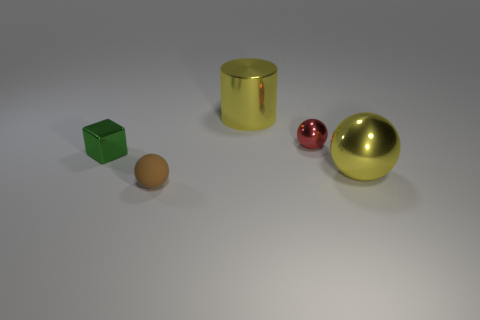What shape is the large metallic object that is the same color as the large ball?
Give a very brief answer. Cylinder. What number of spheres are either yellow things or tiny red shiny things?
Make the answer very short. 2. Is there anything else that is the same shape as the small red thing?
Give a very brief answer. Yes. Are there more metallic balls that are to the left of the cube than tiny balls behind the small red sphere?
Ensure brevity in your answer.  No. How many objects are to the right of the tiny metal thing that is left of the large yellow metal cylinder?
Your answer should be compact. 4. How many objects are either red balls or big blue rubber objects?
Offer a very short reply. 1. Is the brown object the same shape as the green thing?
Make the answer very short. No. What is the material of the tiny brown ball?
Your answer should be very brief. Rubber. How many spheres are both on the right side of the brown matte thing and in front of the red sphere?
Make the answer very short. 1. Do the brown thing and the green object have the same size?
Your response must be concise. Yes. 